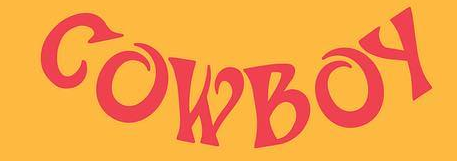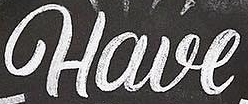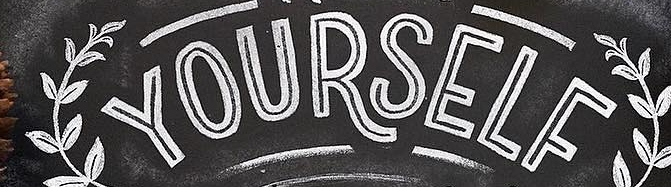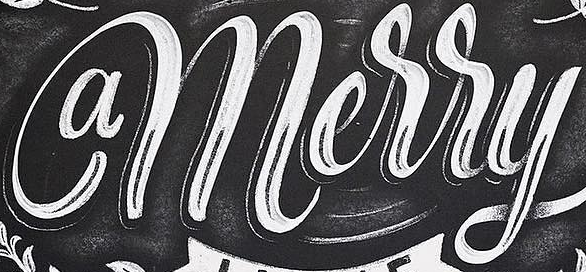Identify the words shown in these images in order, separated by a semicolon. COWBOY; Have; YOURSELF; amerry 